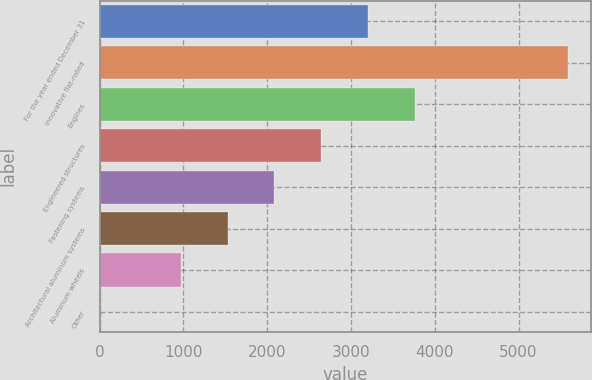Convert chart. <chart><loc_0><loc_0><loc_500><loc_500><bar_chart><fcel>For the year ended December 31<fcel>Innovative flat-rolled<fcel>Engines<fcel>Engineered structures<fcel>Fastening systems<fcel>Architectural aluminum systems<fcel>Aluminum wheels<fcel>Other<nl><fcel>3201.4<fcel>5588<fcel>3759.5<fcel>2643.3<fcel>2085.2<fcel>1527.1<fcel>969<fcel>7<nl></chart> 